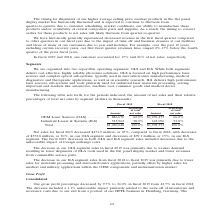According to Coherent's financial document, What led to the decrease in the OLS segment in 2019? primarily due to weaker demand resulting in lower shipments of ELA tools used in the flat panel display market and lower revenues from consumable service parts.. The document states: "crease in our OLS segment sales in fiscal 2019 was primarily due to weaker demand resulting in lower shipments of ELA tools used in the flat panel dis..." Also, What led to the decrease in the ILS segment in 2019? primarily due to lower sales for materials processing and microelectronics applications, partially offset by higher sales for medical and military applications within the OEM components and instrumentation market.. The document states: "segment sales from fiscal 2018 to fiscal 2019 was primarily due to lower sales for materials processing and microelectronics applications, partially o..." Also, In which years was the operating segment data provided? The document shows two values: 2019 and 2018. From the document: "Fiscal 2019 Fiscal 2018 Percentage Percentage of total of total Amount net sales Amount net sales Fiscal 2019 Fiscal 2018 Percentage Percentage of tot..." Additionally, In which year was ILS a higher percentage of total net sales? According to the financial document, 2019. The relevant text states: "Fiscal 2019 Fiscal 2018 Percentage Percentage of total of total Amount net sales Amount net sales..." Also, can you calculate: What was the average amount of net sales for OLS in 2018 and 2019? To answer this question, I need to perform calculations using the financial data. The calculation is: (886,676+1,259,477)/2, which equals 1073076.5 (in thousands). This is based on the information: "OEM Laser Sources (OLS) . $ 886,676 62.0% $1,259,477 66.2% Industrial Lasers & Systems (ILS) . 543,964 38.0% 643,096 33.8% OEM Laser Sources (OLS) . $ 886,676 62.0% $1,259,477 66.2% Industrial Lasers ..." The key data points involved are: 1,259,477, 886,676. Also, can you calculate: What was the average amount of net sales for ILS in 2018 and 2019? To answer this question, I need to perform calculations using the financial data. The calculation is: (543,964+643,096)/2, which equals 593530 (in thousands). This is based on the information: "259,477 66.2% Industrial Lasers & Systems (ILS) . 543,964 38.0% 643,096 33.8% Industrial Lasers & Systems (ILS) . 543,964 38.0% 643,096 33.8%..." The key data points involved are: 543,964, 643,096. 